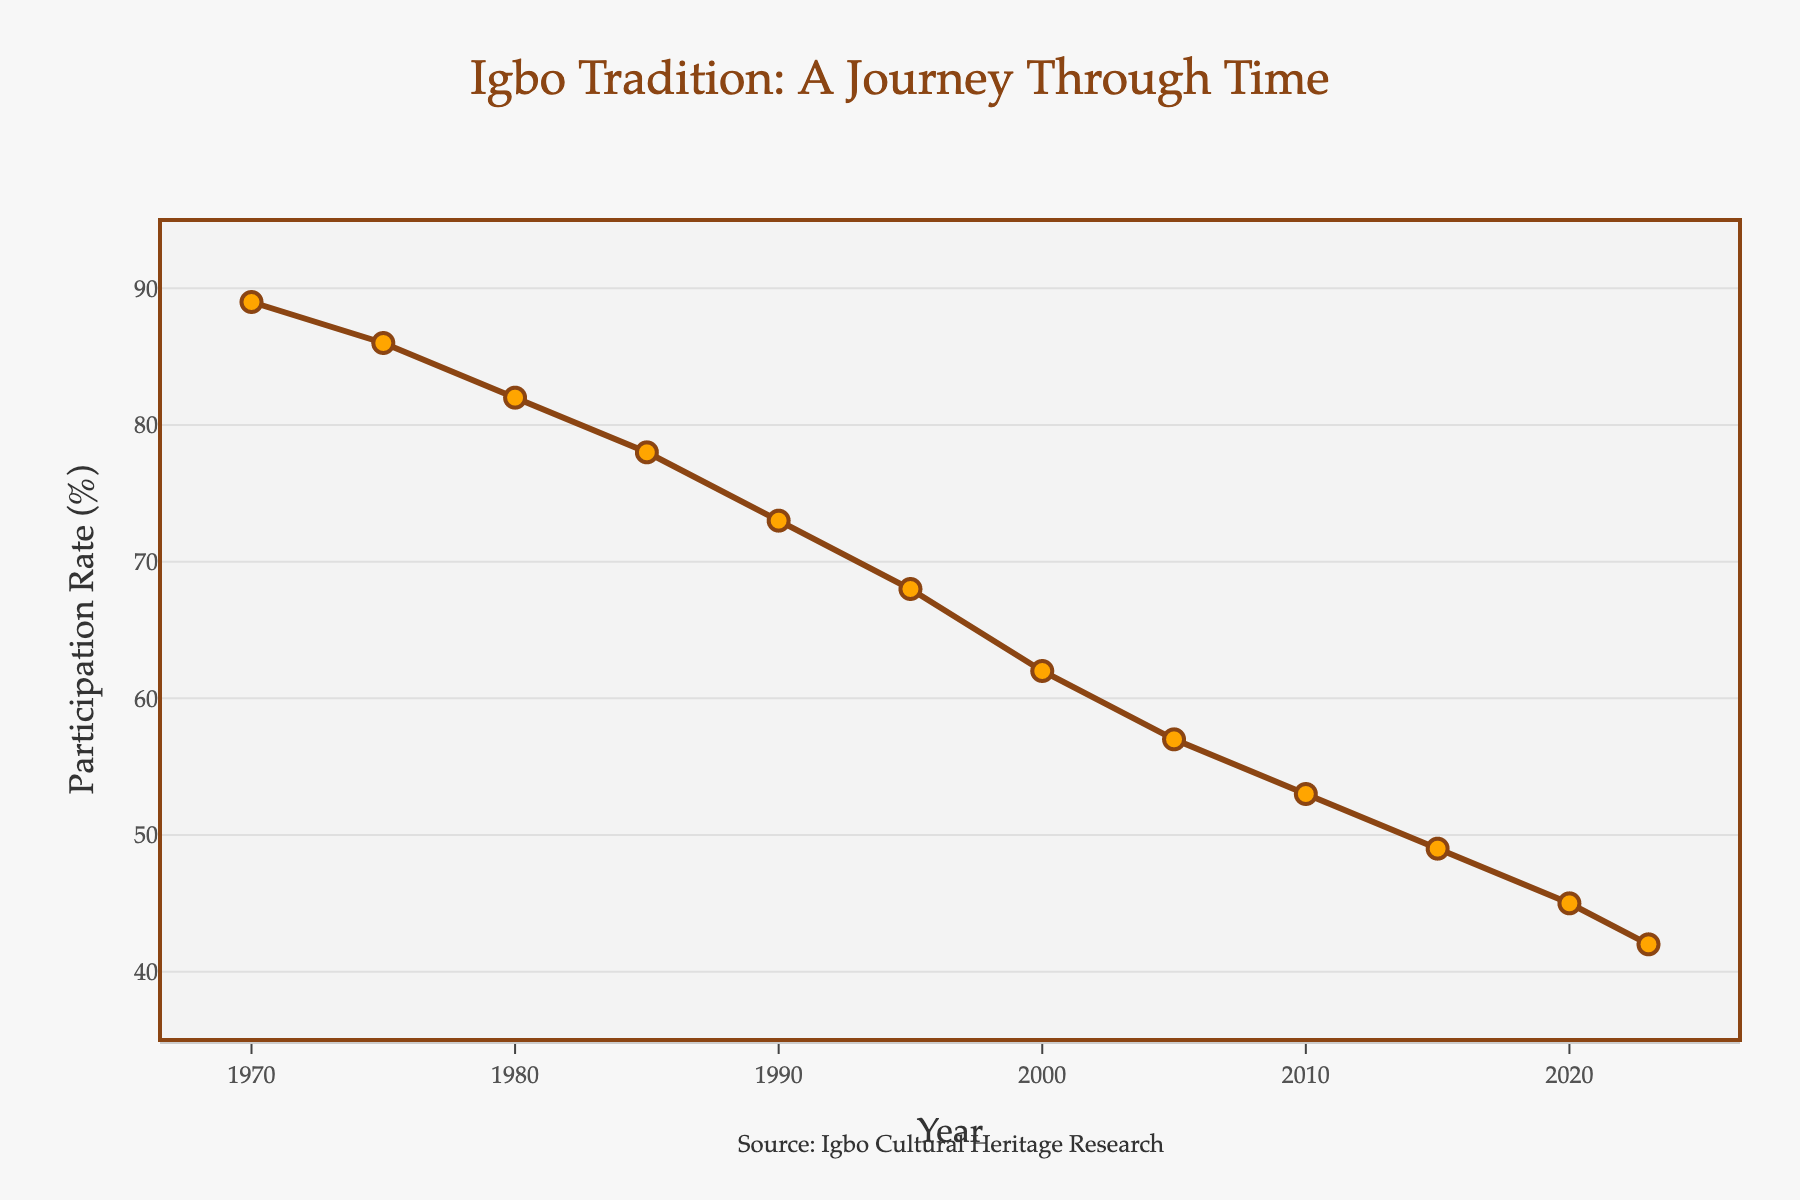What's the participation rate in 1985? Look at the data point corresponding to the year 1985, where the "Participation Rate (%)" is shown.
Answer: 78 What is the trend of the participation rate from 1970 to 2000? Observe the overall direction of the line graph from 1970 to 2000. The line shows a continuous decline.
Answer: Decreasing What is the average participation rate from 1990 to 2020? Add the participation rates for the years 1990, 1995, 2000, 2005, 2010, 2015, and 2020, then divide by the number of years. (73 + 68 + 62 + 57 + 53 + 49 + 45) / 7 = 407 / 7 = 58.14
Answer: 58.14 Which year had the highest participation rate and what was it? Look at the data points and identify the year with the highest participation rate. The year 1970 has the highest value.
Answer: 1970, 89 By how much has the participation rate declined from 1970 to 2023? Subtract the participation rate in 2023 from the participation rate in 1970. 89 (1970) - 42 (2023) = 47
Answer: 47 What is the participation rate difference between 2005 and 2015? Subtract the participation rate in 2015 from the participation rate in 2005. 57 (2005) - 49 (2015) = 8
Answer: 8 Which year shows the largest drop in participation rate within five-year intervals? Calculate the differences for each five-year interval and find the maximum drop between consecutive data points. The largest drop is between 1970 (89) and 1975 (86) which is 3.
Answer: 1970-1975 How does the participation rate change visually from 2010 onwards? Observe the shape and direction of the line from 2010 to the present. The line shows a continuous downward slope.
Answer: Decreasing steadily Which decade witnessed the steepest decline in participation rate? Calculate the total decline in participation rate for each decade and compare them. The steepest decline is between 1970 and 1980: 89 (1970) - 82 (1980) = 7.
Answer: 1970-1980 